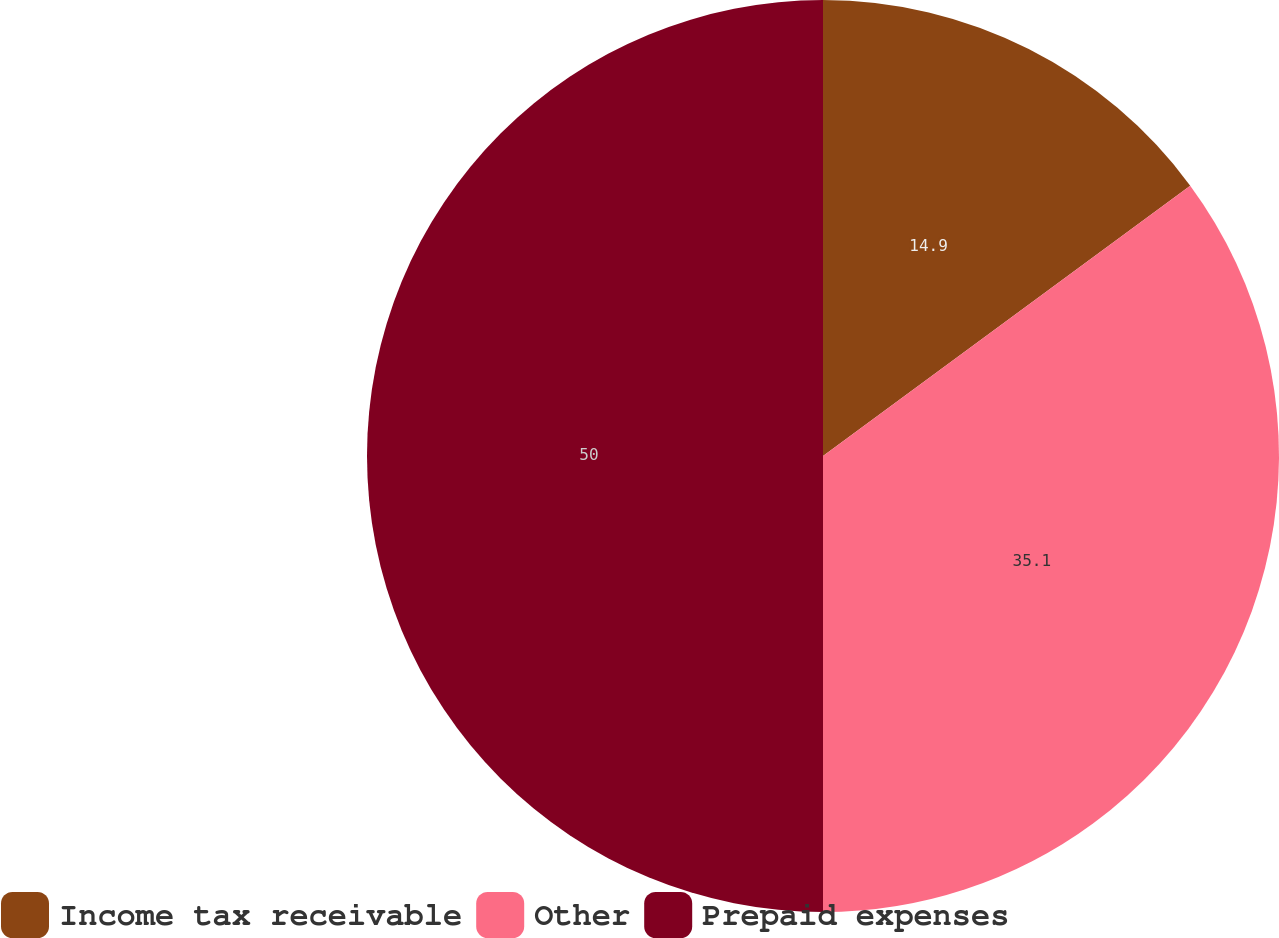<chart> <loc_0><loc_0><loc_500><loc_500><pie_chart><fcel>Income tax receivable<fcel>Other<fcel>Prepaid expenses<nl><fcel>14.9%<fcel>35.1%<fcel>50.0%<nl></chart> 